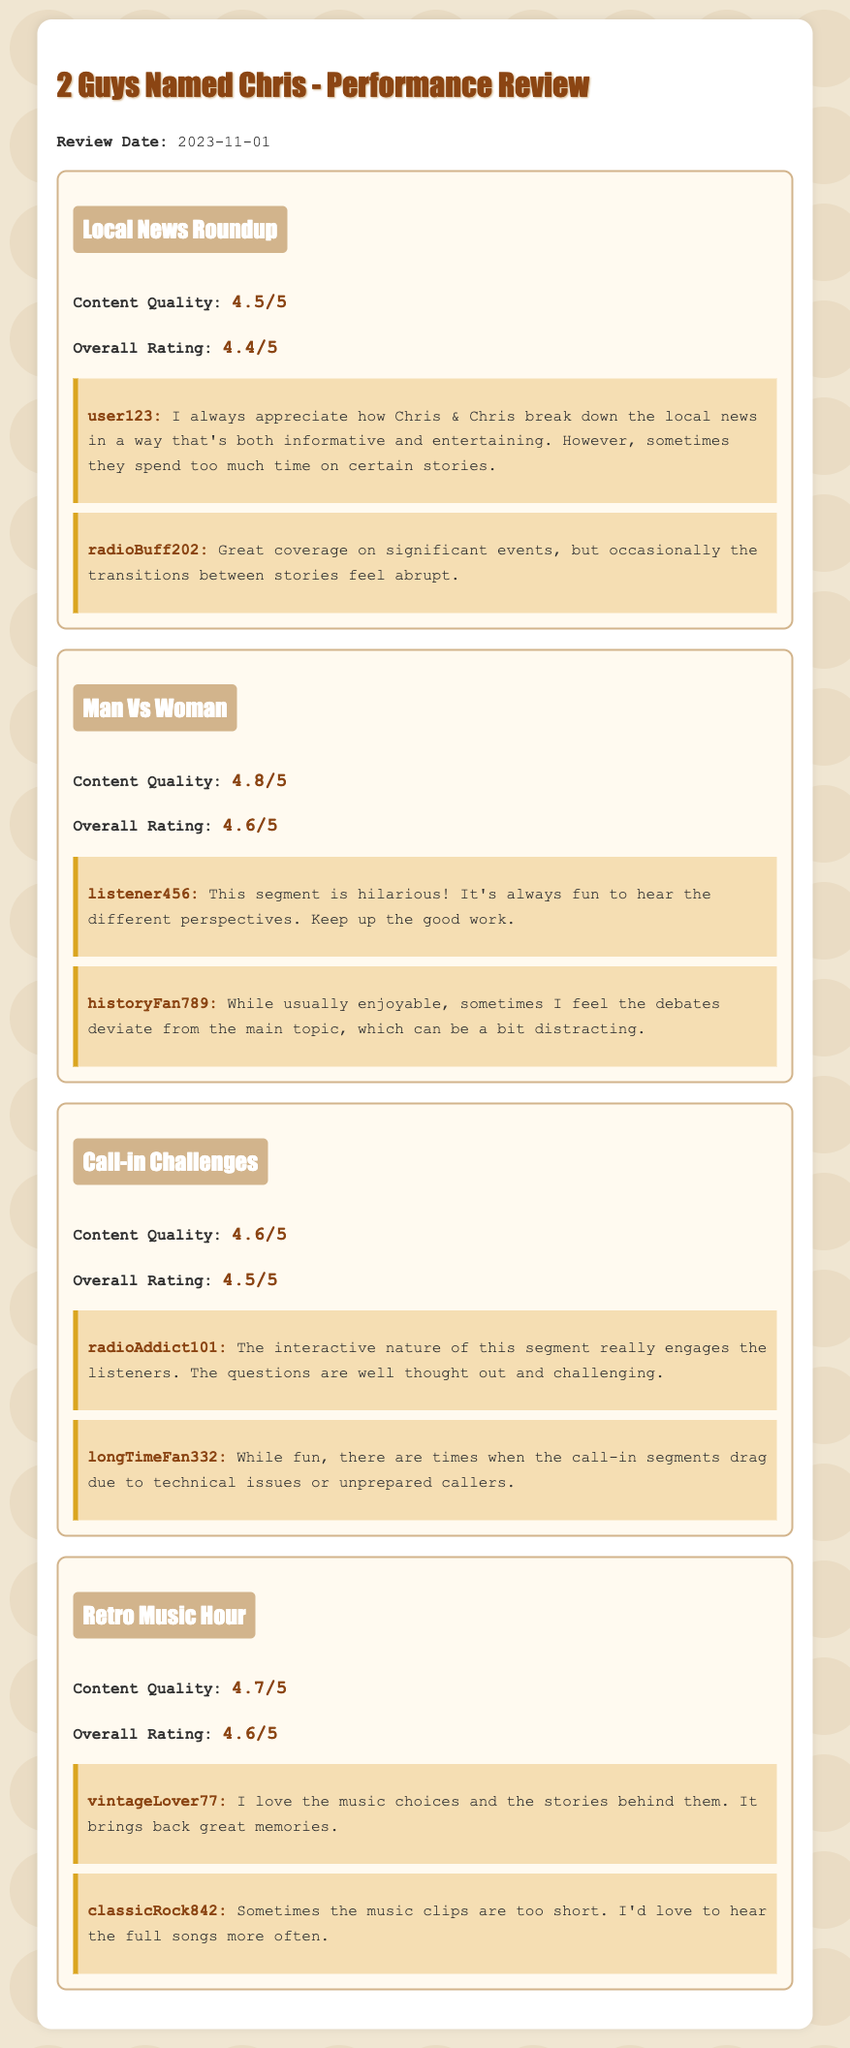What is the title of the performance review document? The title of the document is stated prominently at the top, which is "2 Guys Named Chris - Performance Review."
Answer: 2 Guys Named Chris - Performance Review What is the review date? The review date is specified in the document as "2023-11-01."
Answer: 2023-11-01 What is the overall rating for the "Local News Roundup" segment? The overall rating is directly mentioned in relation to that segment, which is "4.4/5."
Answer: 4.4/5 Which segment received the highest content quality rating? The content quality ratings are listed, and the highest one is for the "Man Vs Woman" segment at "4.8/5."
Answer: Man Vs Woman Who provided feedback indicating that the transitions felt abrupt? The listener username who mentioned abrupt transitions is provided in the feedback for that segment, which is "radioBuff202."
Answer: radioBuff202 What is the general focus of the "Call-in Challenges" segment? The document describes the "Call-in Challenges" segment as being interactive and engaging, emphasizing the nature of listener participation.
Answer: Interactive nature How many listener feedback entries are provided for the "Retro Music Hour"? The document lists the number of feedback entries for this segment, which is two.
Answer: Two Which segment mentions a preference for longer music clips? The feedback specifically points out this preference regarding the "Retro Music Hour" segment.
Answer: Retro Music Hour What was the content quality rating for the "Man Vs Woman" segment? This specific rating is stated in the performance review, which is "4.8/5."
Answer: 4.8/5 